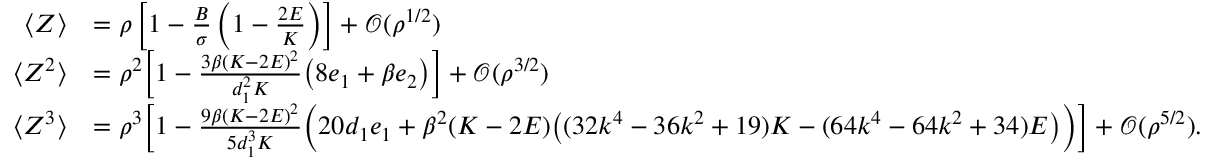<formula> <loc_0><loc_0><loc_500><loc_500>\begin{array} { r l } { \langle Z \rangle } & { = \rho \left [ 1 - \frac { B } { \sigma } \left ( 1 - \frac { 2 E } { K } \right ) \right ] + \ m a t h s c r { O } ( \rho ^ { 1 / 2 } ) } \\ { \langle Z ^ { 2 } \rangle } & { = \rho ^ { 2 } \left [ 1 - \frac { 3 \beta ( K - 2 E ) ^ { 2 } } { d _ { 1 } ^ { 2 } K } \left ( 8 e _ { 1 } + \beta e _ { 2 } \right ) \right ] + \ m a t h s c r { O } ( \rho ^ { 3 / 2 } ) } \\ { \langle Z ^ { 3 } \rangle } & { = \rho ^ { 3 } \left [ 1 - \frac { 9 \beta ( K - 2 E ) ^ { 2 } } { 5 d _ { 1 } ^ { 3 } K } \left ( 2 0 d _ { 1 } e _ { 1 } + \beta ^ { 2 } ( K - 2 E ) \left ( ( 3 2 k ^ { 4 } - 3 6 k ^ { 2 } + 1 9 ) K - ( 6 4 k ^ { 4 } - 6 4 k ^ { 2 } + 3 4 ) E \right ) \right ) \right ] + \ m a t h s c r { O } ( \rho ^ { 5 / 2 } ) . } \end{array}</formula> 